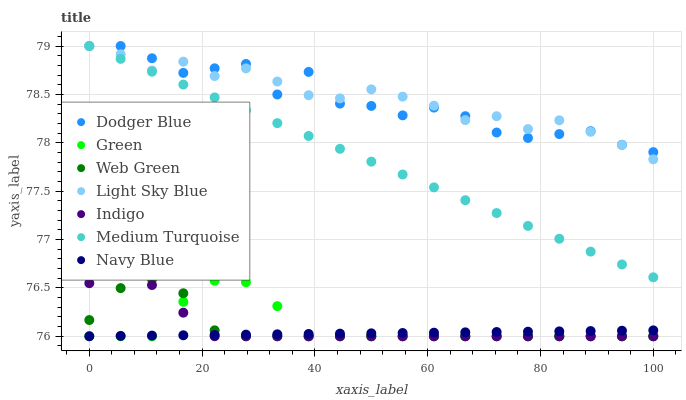Does Navy Blue have the minimum area under the curve?
Answer yes or no. Yes. Does Light Sky Blue have the maximum area under the curve?
Answer yes or no. Yes. Does Web Green have the minimum area under the curve?
Answer yes or no. No. Does Web Green have the maximum area under the curve?
Answer yes or no. No. Is Medium Turquoise the smoothest?
Answer yes or no. Yes. Is Dodger Blue the roughest?
Answer yes or no. Yes. Is Navy Blue the smoothest?
Answer yes or no. No. Is Navy Blue the roughest?
Answer yes or no. No. Does Indigo have the lowest value?
Answer yes or no. Yes. Does Light Sky Blue have the lowest value?
Answer yes or no. No. Does Dodger Blue have the highest value?
Answer yes or no. Yes. Does Web Green have the highest value?
Answer yes or no. No. Is Web Green less than Light Sky Blue?
Answer yes or no. Yes. Is Medium Turquoise greater than Navy Blue?
Answer yes or no. Yes. Does Navy Blue intersect Green?
Answer yes or no. Yes. Is Navy Blue less than Green?
Answer yes or no. No. Is Navy Blue greater than Green?
Answer yes or no. No. Does Web Green intersect Light Sky Blue?
Answer yes or no. No. 